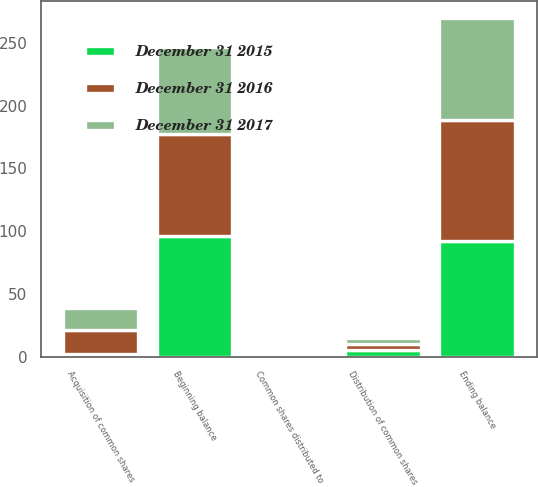<chart> <loc_0><loc_0><loc_500><loc_500><stacked_bar_chart><ecel><fcel>Beginning balance<fcel>Acquisition of common shares<fcel>Distribution of common shares<fcel>Common shares distributed to<fcel>Ending balance<nl><fcel>December 31 2015<fcel>95.9<fcel>1.9<fcel>5.2<fcel>0.2<fcel>92.4<nl><fcel>December 31 2016<fcel>81.3<fcel>19.6<fcel>4.7<fcel>0.3<fcel>95.9<nl><fcel>December 31 2017<fcel>69.4<fcel>17.4<fcel>5.2<fcel>0.1<fcel>81.3<nl></chart> 